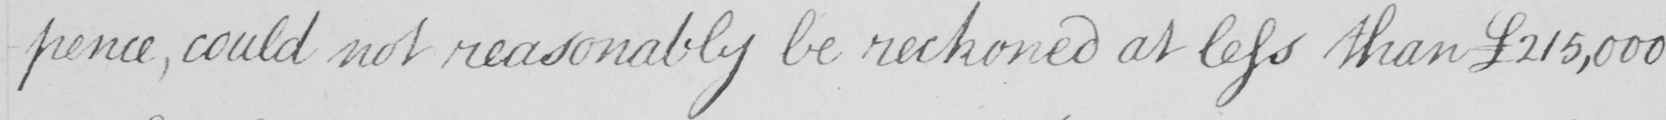Can you read and transcribe this handwriting? -pence , could not reasonably be reckoned at less than  £215,000 